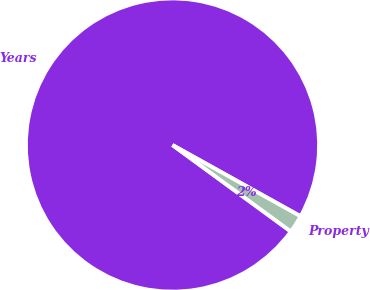<chart> <loc_0><loc_0><loc_500><loc_500><pie_chart><fcel>Years<fcel>Property<nl><fcel>98.04%<fcel>1.96%<nl></chart> 